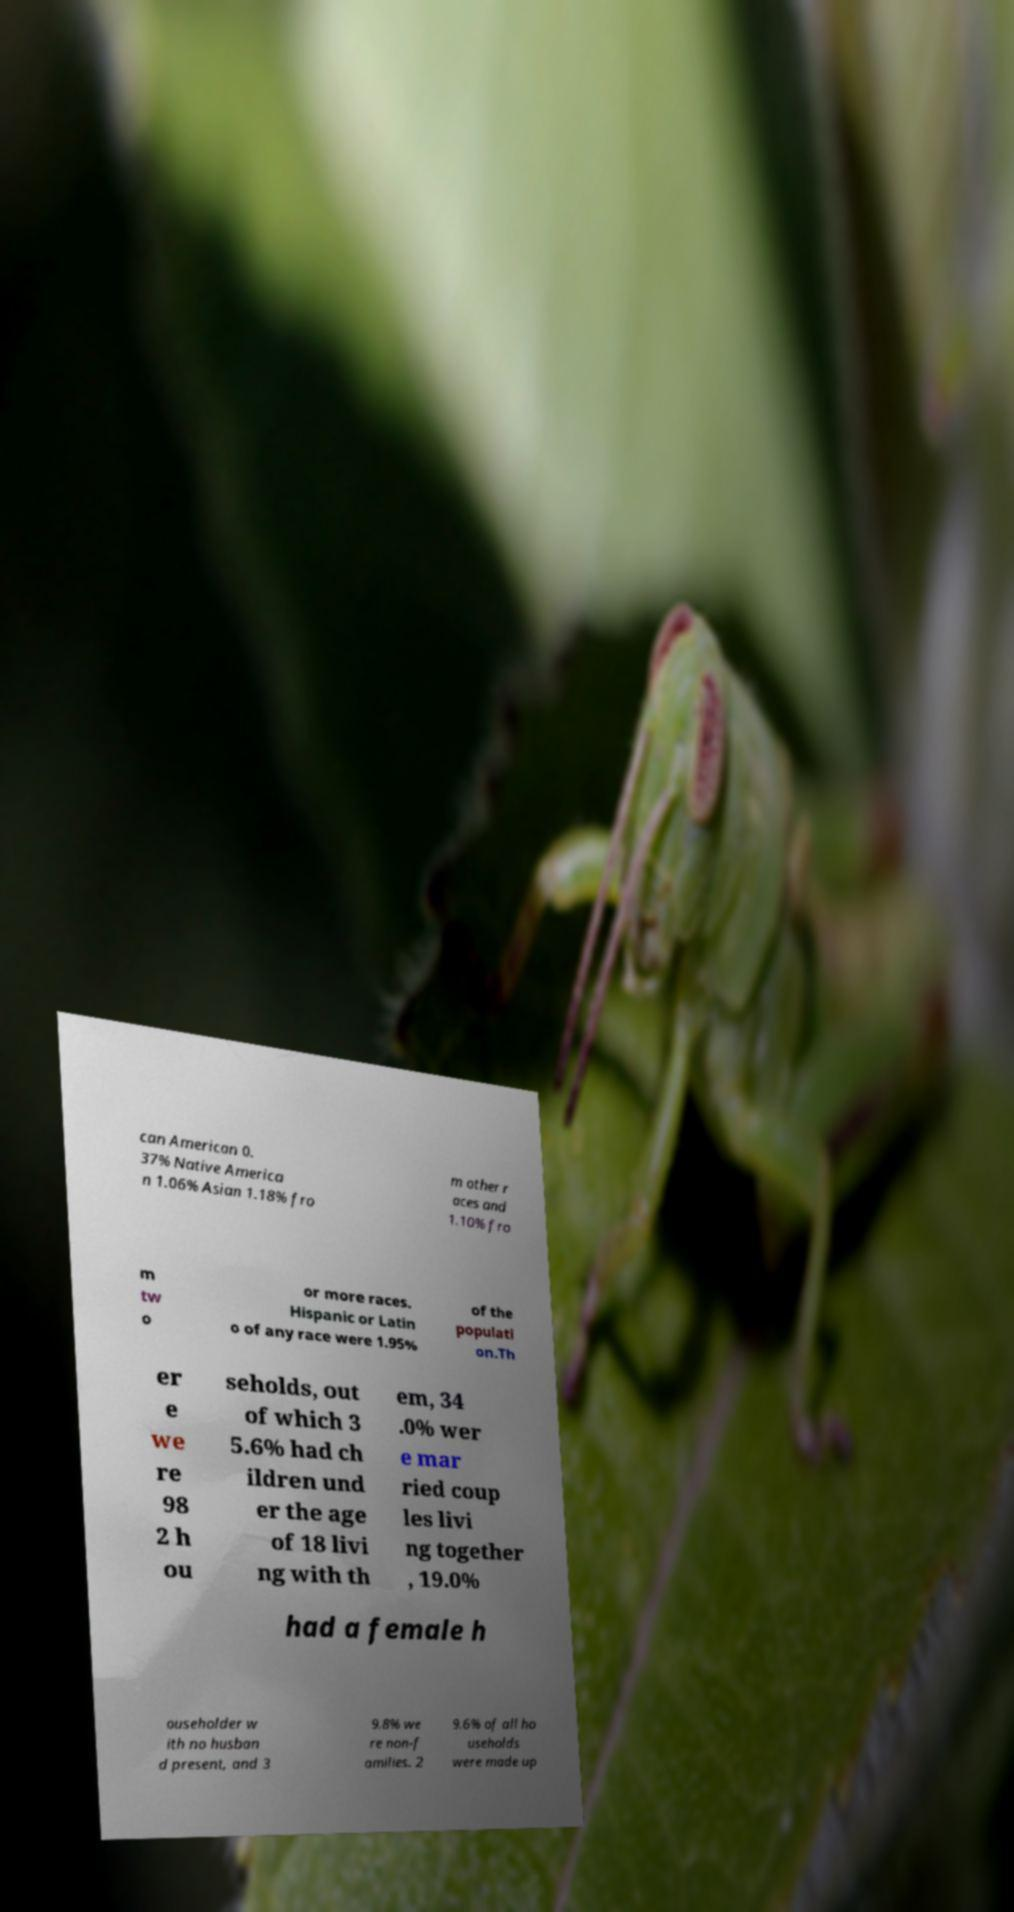Can you read and provide the text displayed in the image?This photo seems to have some interesting text. Can you extract and type it out for me? can American 0. 37% Native America n 1.06% Asian 1.18% fro m other r aces and 1.10% fro m tw o or more races. Hispanic or Latin o of any race were 1.95% of the populati on.Th er e we re 98 2 h ou seholds, out of which 3 5.6% had ch ildren und er the age of 18 livi ng with th em, 34 .0% wer e mar ried coup les livi ng together , 19.0% had a female h ouseholder w ith no husban d present, and 3 9.8% we re non-f amilies. 2 9.6% of all ho useholds were made up 